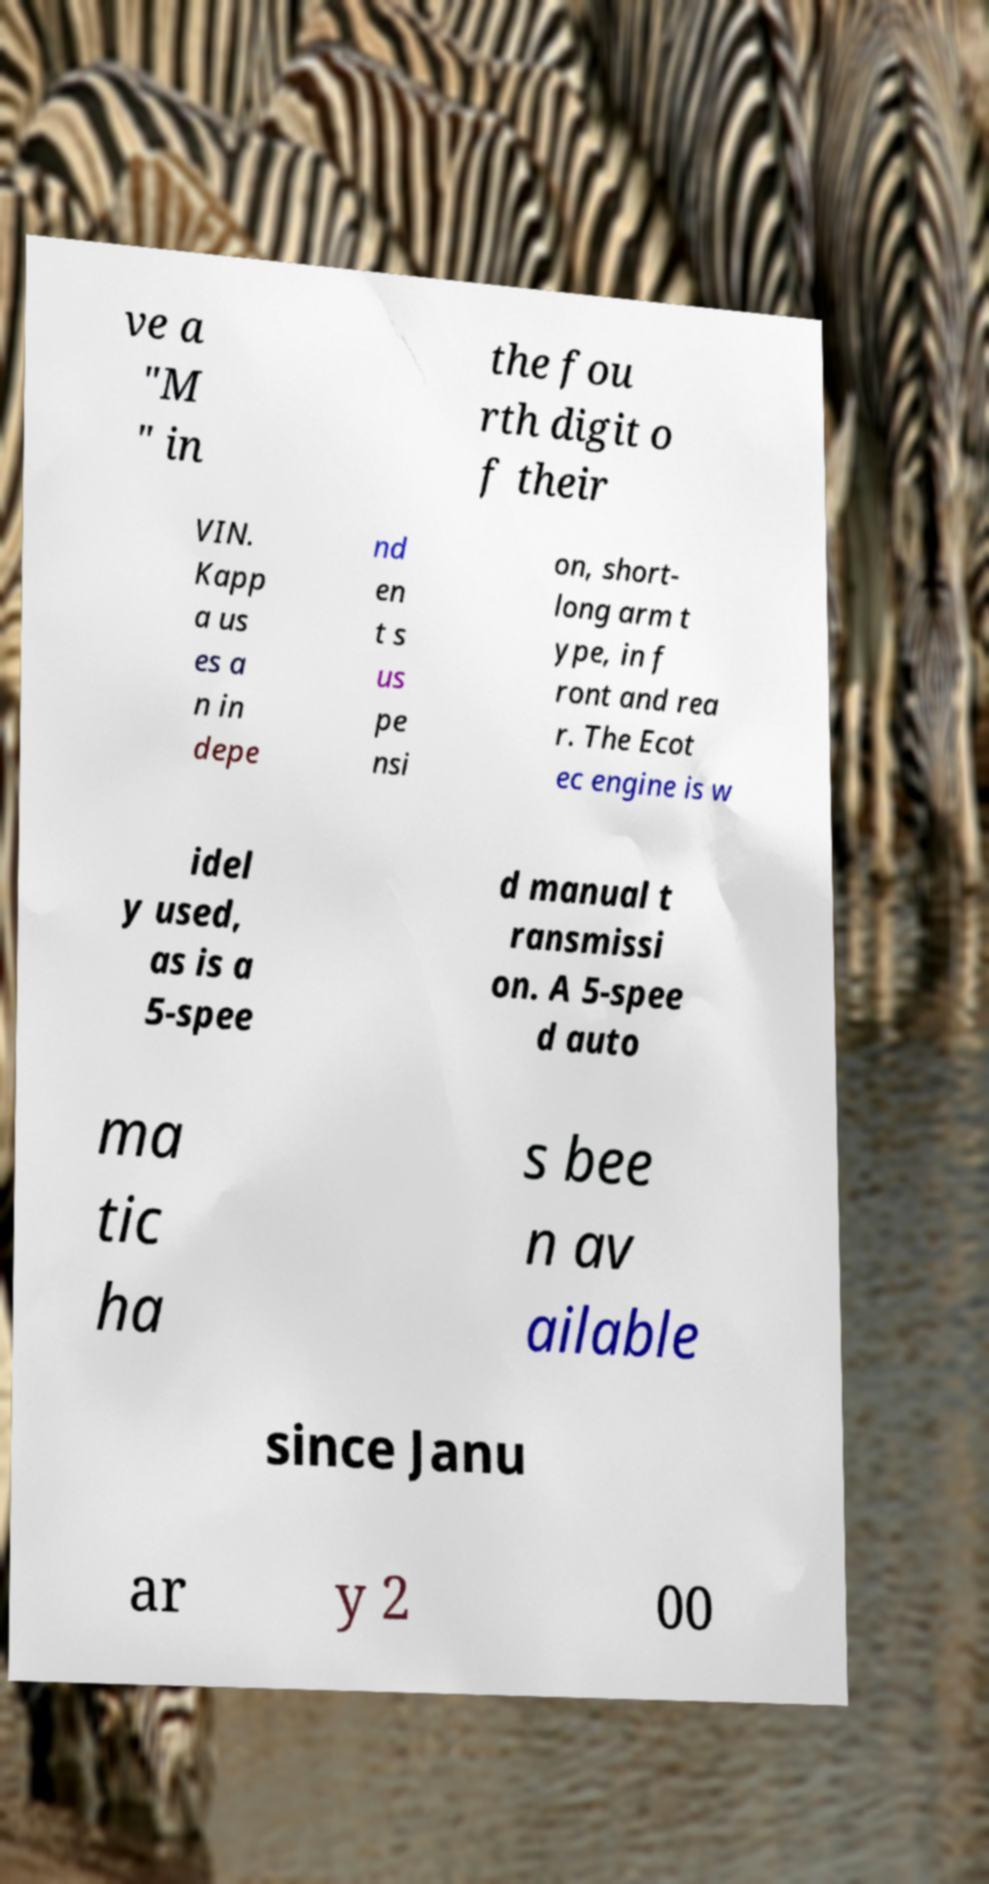I need the written content from this picture converted into text. Can you do that? ve a "M " in the fou rth digit o f their VIN. Kapp a us es a n in depe nd en t s us pe nsi on, short- long arm t ype, in f ront and rea r. The Ecot ec engine is w idel y used, as is a 5-spee d manual t ransmissi on. A 5-spee d auto ma tic ha s bee n av ailable since Janu ar y 2 00 